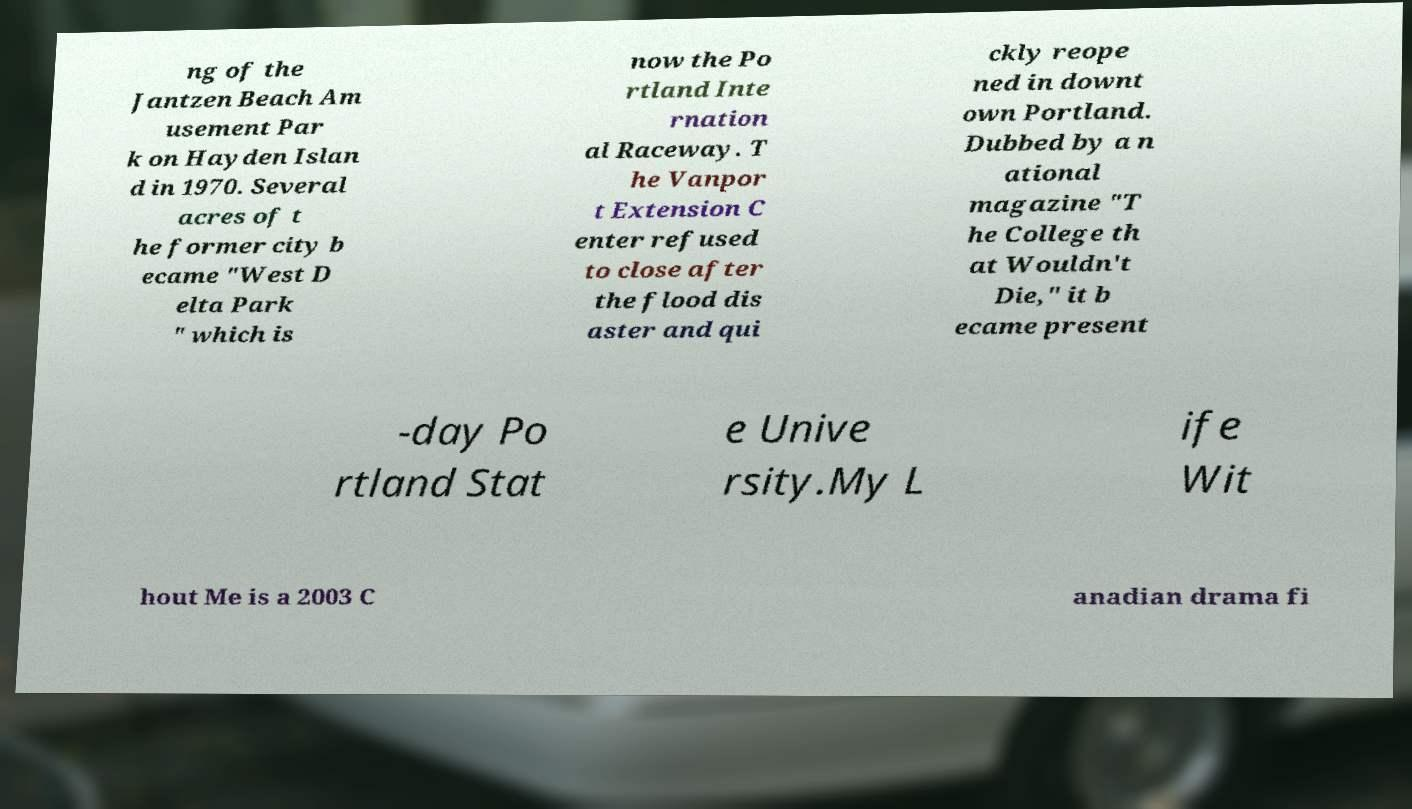Can you accurately transcribe the text from the provided image for me? ng of the Jantzen Beach Am usement Par k on Hayden Islan d in 1970. Several acres of t he former city b ecame "West D elta Park " which is now the Po rtland Inte rnation al Raceway. T he Vanpor t Extension C enter refused to close after the flood dis aster and qui ckly reope ned in downt own Portland. Dubbed by a n ational magazine "T he College th at Wouldn't Die," it b ecame present -day Po rtland Stat e Unive rsity.My L ife Wit hout Me is a 2003 C anadian drama fi 